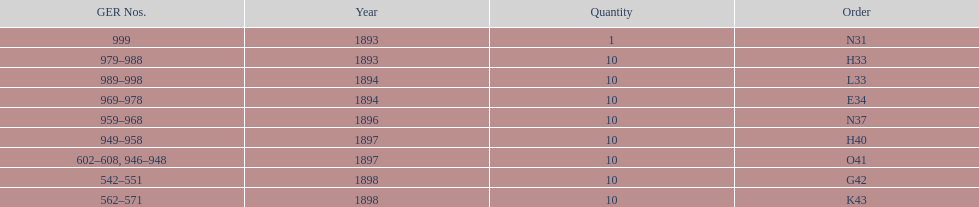Help me parse the entirety of this table. {'header': ['GER Nos.', 'Year', 'Quantity', 'Order'], 'rows': [['999', '1893', '1', 'N31'], ['979–988', '1893', '10', 'H33'], ['989–998', '1894', '10', 'L33'], ['969–978', '1894', '10', 'E34'], ['959–968', '1896', '10', 'N37'], ['949–958', '1897', '10', 'H40'], ['602–608, 946–948', '1897', '10', 'O41'], ['542–551', '1898', '10', 'G42'], ['562–571', '1898', '10', 'K43']]} What amount of time to the years span? 5 years. 